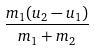Convert formula to latex. <formula><loc_0><loc_0><loc_500><loc_500>\frac { m _ { 1 } ( u _ { 2 } - u _ { 1 } ) } { m _ { 1 } + m _ { 2 } }</formula> 